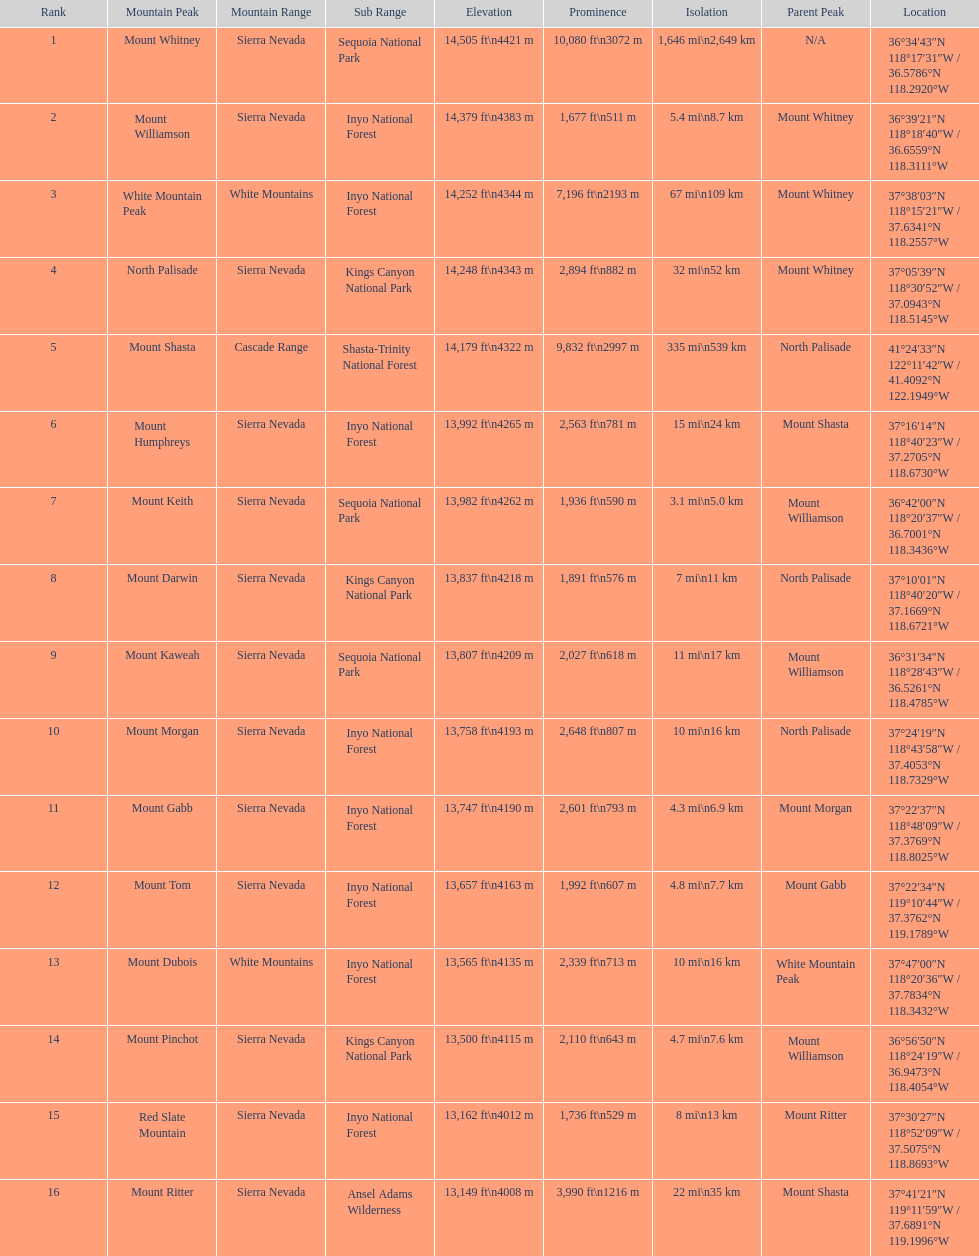What is the next highest mountain peak after north palisade? Mount Shasta. 